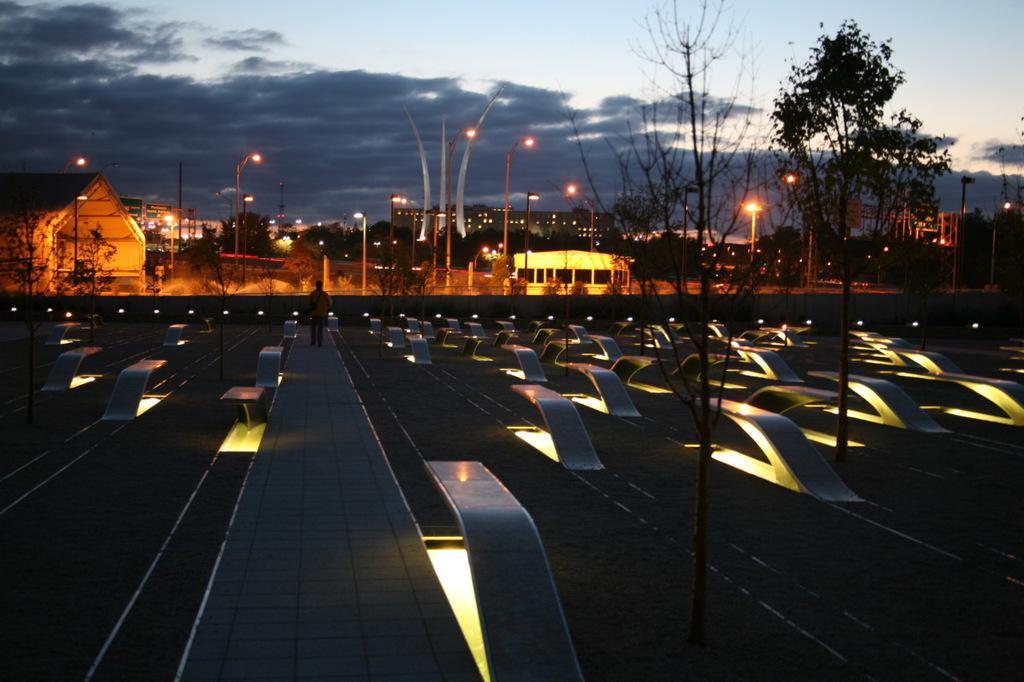In one or two sentences, can you explain what this image depicts? In this picture I can see there is a person walking here and in the backdrop there are plants, trees and buildings, there are street lights and some poles and the sky is clear. 